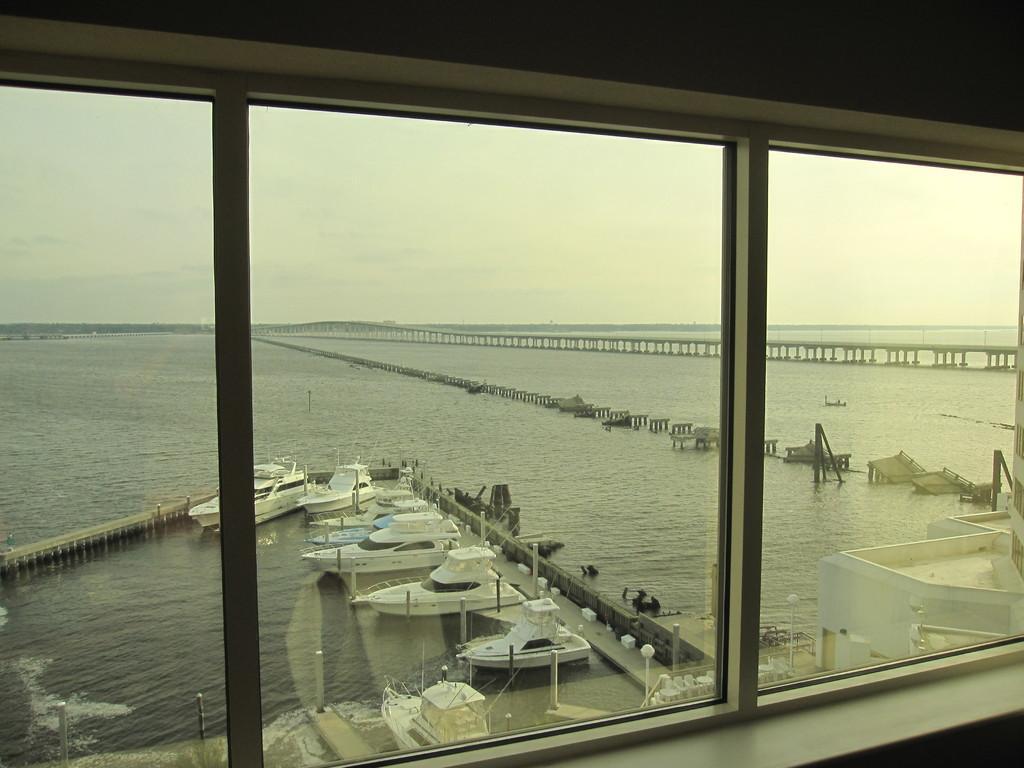Describe this image in one or two sentences. In this picture we can see a window,from window we can see boats on water and we can see sky in the background. 